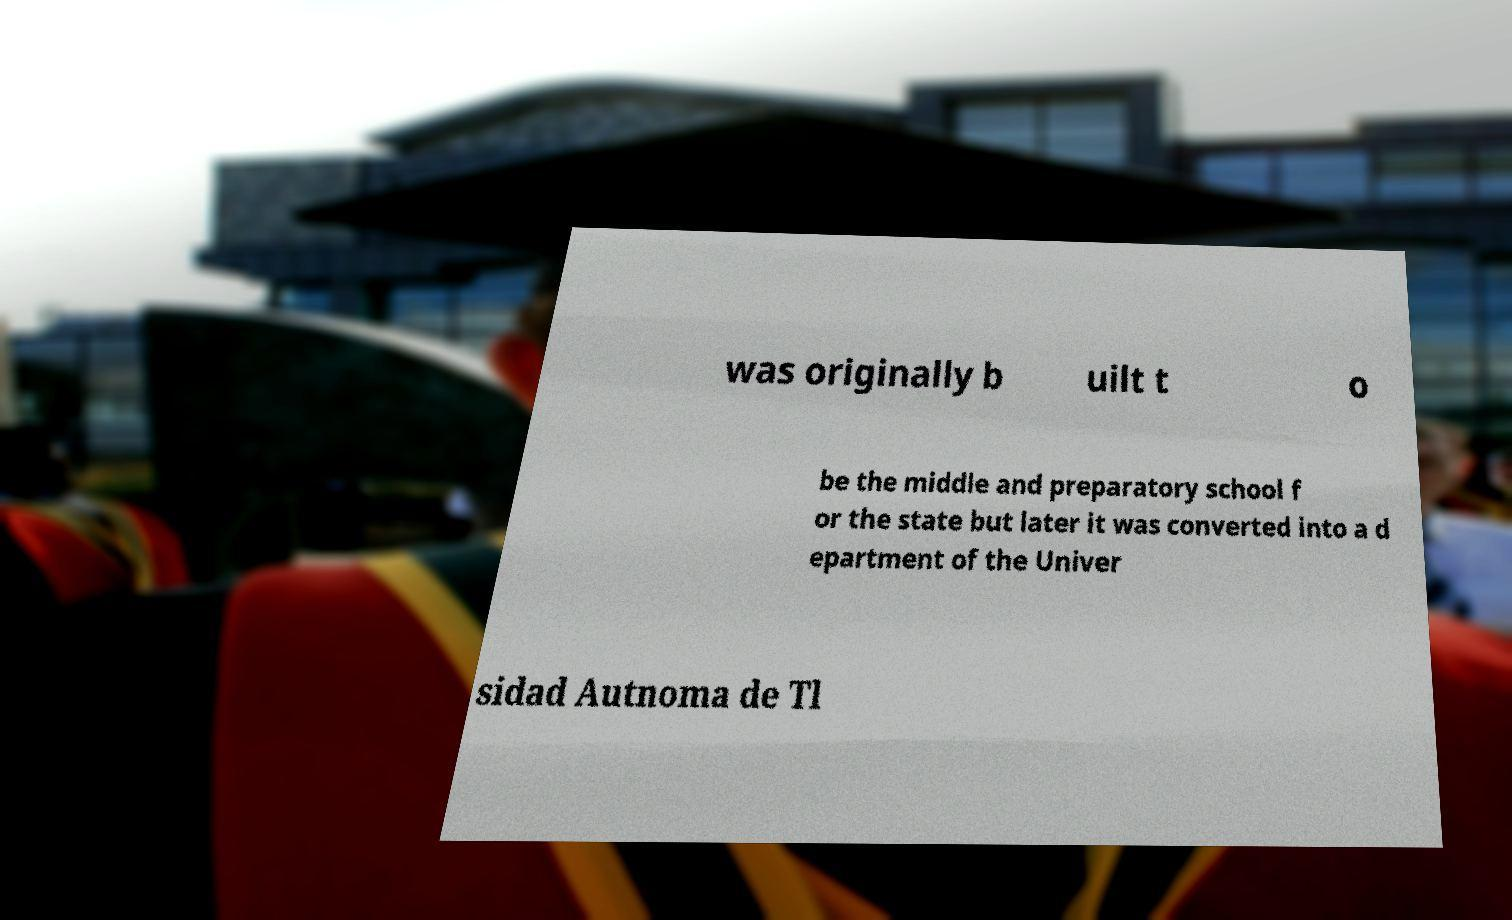Could you assist in decoding the text presented in this image and type it out clearly? was originally b uilt t o be the middle and preparatory school f or the state but later it was converted into a d epartment of the Univer sidad Autnoma de Tl 